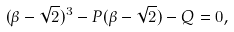Convert formula to latex. <formula><loc_0><loc_0><loc_500><loc_500>( \beta - \sqrt { 2 } ) ^ { 3 } - P ( \beta - \sqrt { 2 } ) - Q = 0 ,</formula> 